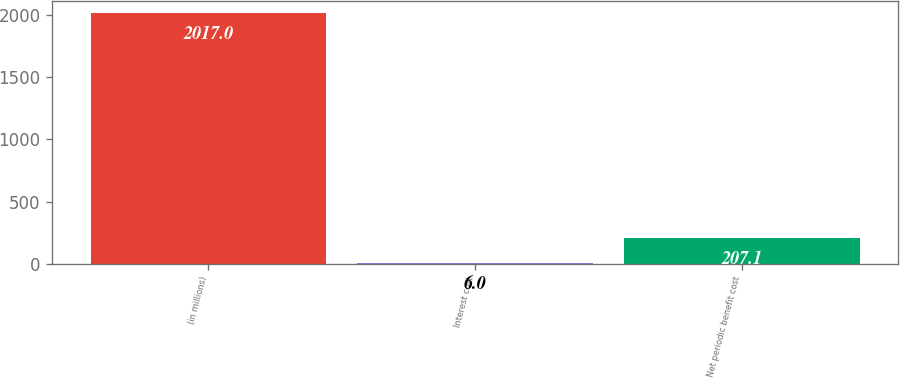<chart> <loc_0><loc_0><loc_500><loc_500><bar_chart><fcel>(in millions)<fcel>Interest cost<fcel>Net periodic benefit cost<nl><fcel>2017<fcel>6<fcel>207.1<nl></chart> 